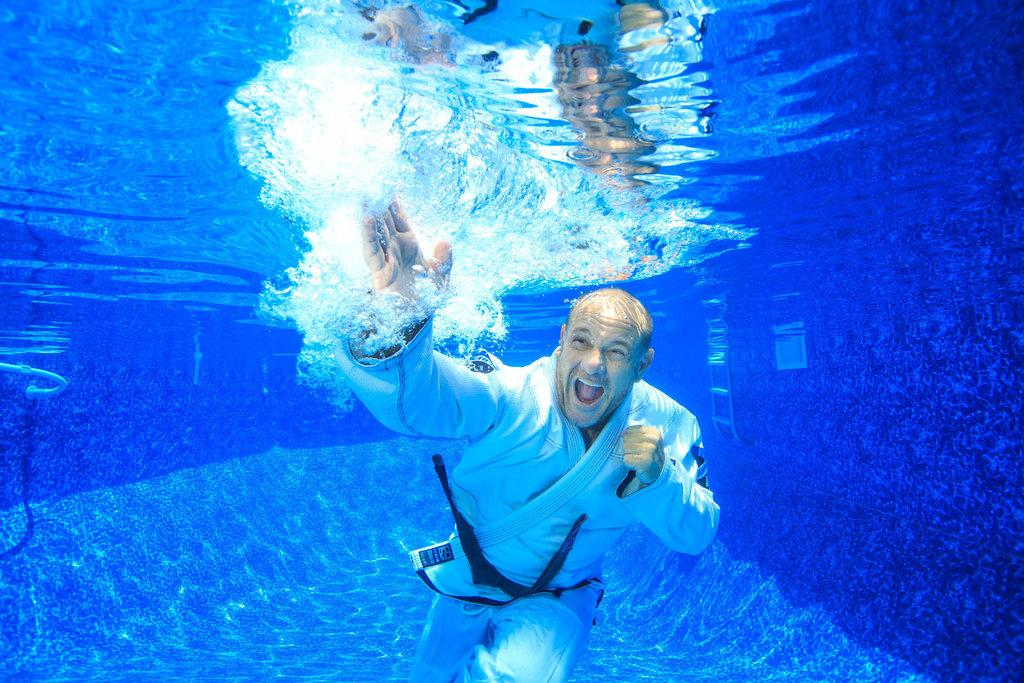Who is the person in the image? There is a man in the image. What is the man doing in the image? The man is practicing martial arts. Where is the martial arts practice taking place? The martial arts practice is taking place inside the water. Who is the coach standing on the side of the pool, providing guidance to the man? There is no coach present in the image; it only shows the man practicing martial arts inside the water. 